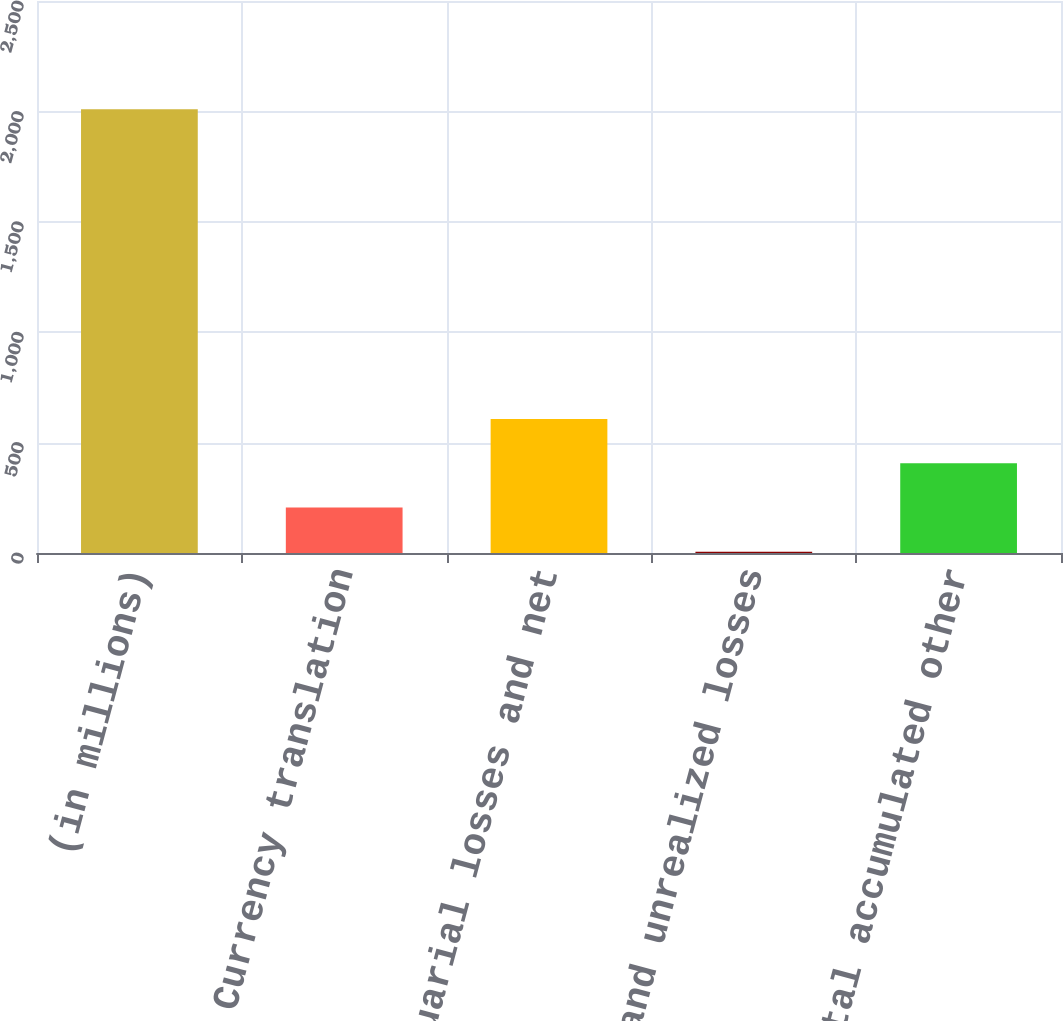<chart> <loc_0><loc_0><loc_500><loc_500><bar_chart><fcel>(in millions)<fcel>Currency translation<fcel>Net actuarial losses and net<fcel>Realized and unrealized losses<fcel>Total accumulated other<nl><fcel>2010<fcel>206.04<fcel>606.92<fcel>5.6<fcel>406.48<nl></chart> 